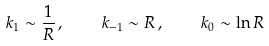<formula> <loc_0><loc_0><loc_500><loc_500>k _ { 1 } \sim \frac { 1 } { R } \, , \quad k _ { - 1 } \sim R \, , \quad k _ { 0 } \sim \ln R</formula> 